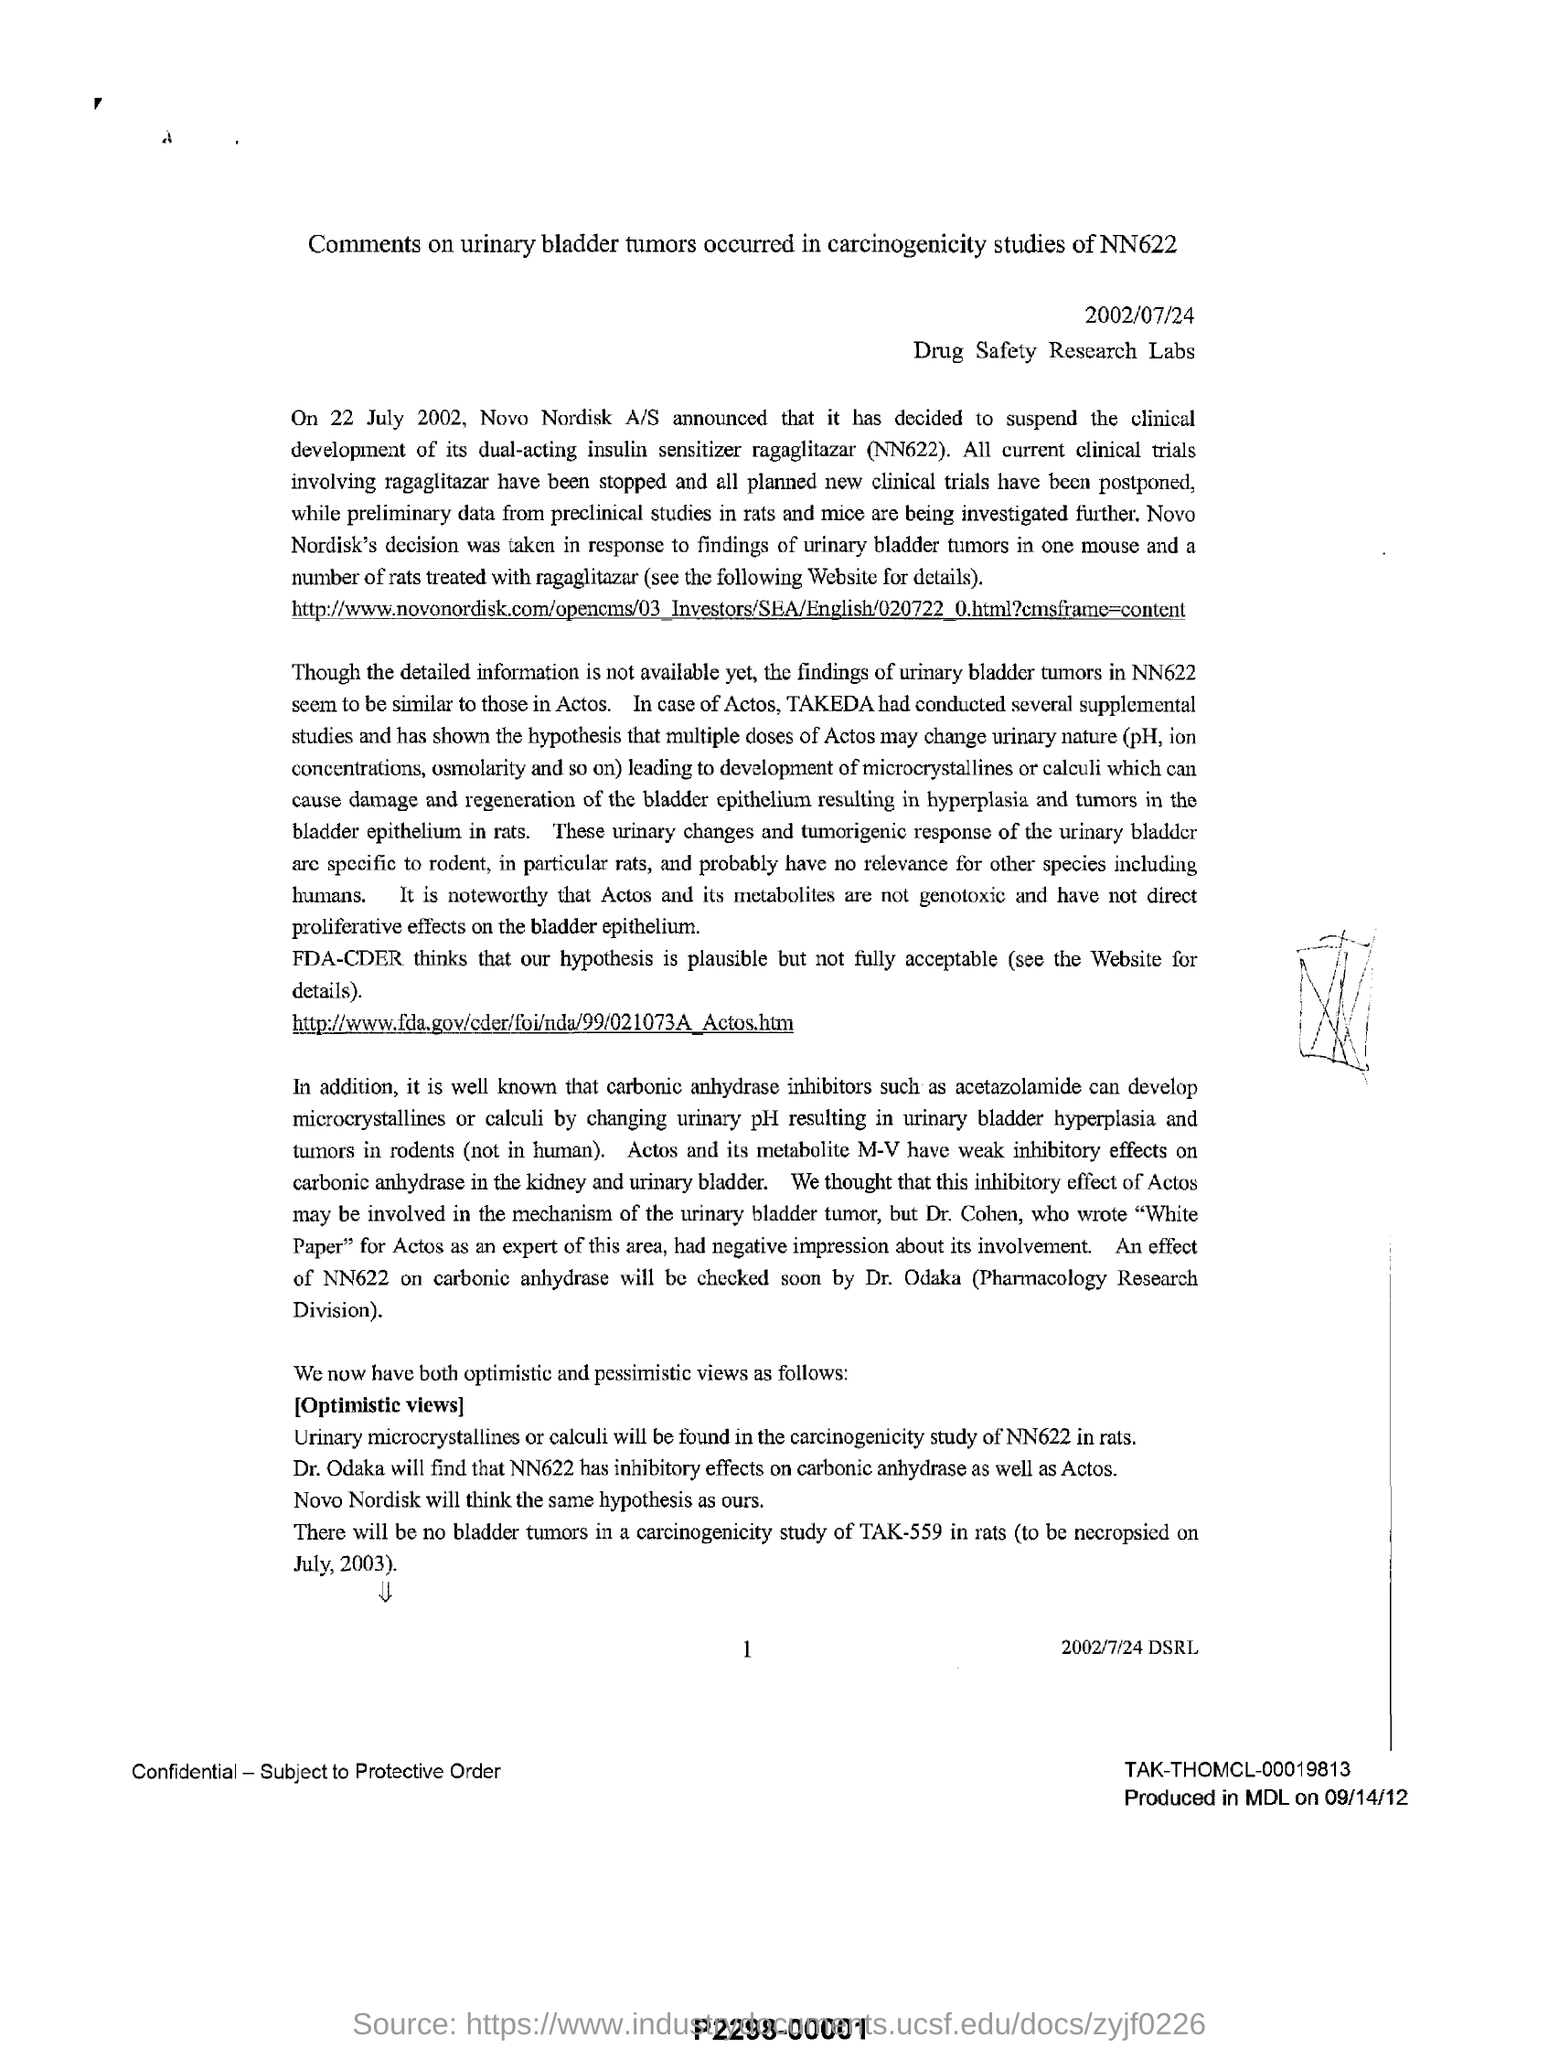What is the date on the document?
Offer a terse response. 2002/07/24. On 22 July 2002, who announced that it had decided to suspend the clinical development of its dual-acting insulin sensitizer ragaglitazar (NN622)?
Provide a succinct answer. Novo Nordisk A/S. What will be found in the carcinogenicity study of NN622 in rats?
Your answer should be compact. Urinary microcrystallines or calculi. Who will find that NN622 has inhibitory effects on carbonic anhydrase as well as actos?
Give a very brief answer. Dr. Odaka. Where was it produced in?
Your response must be concise. MDL. When was it produced?
Make the answer very short. 09/14/12. 